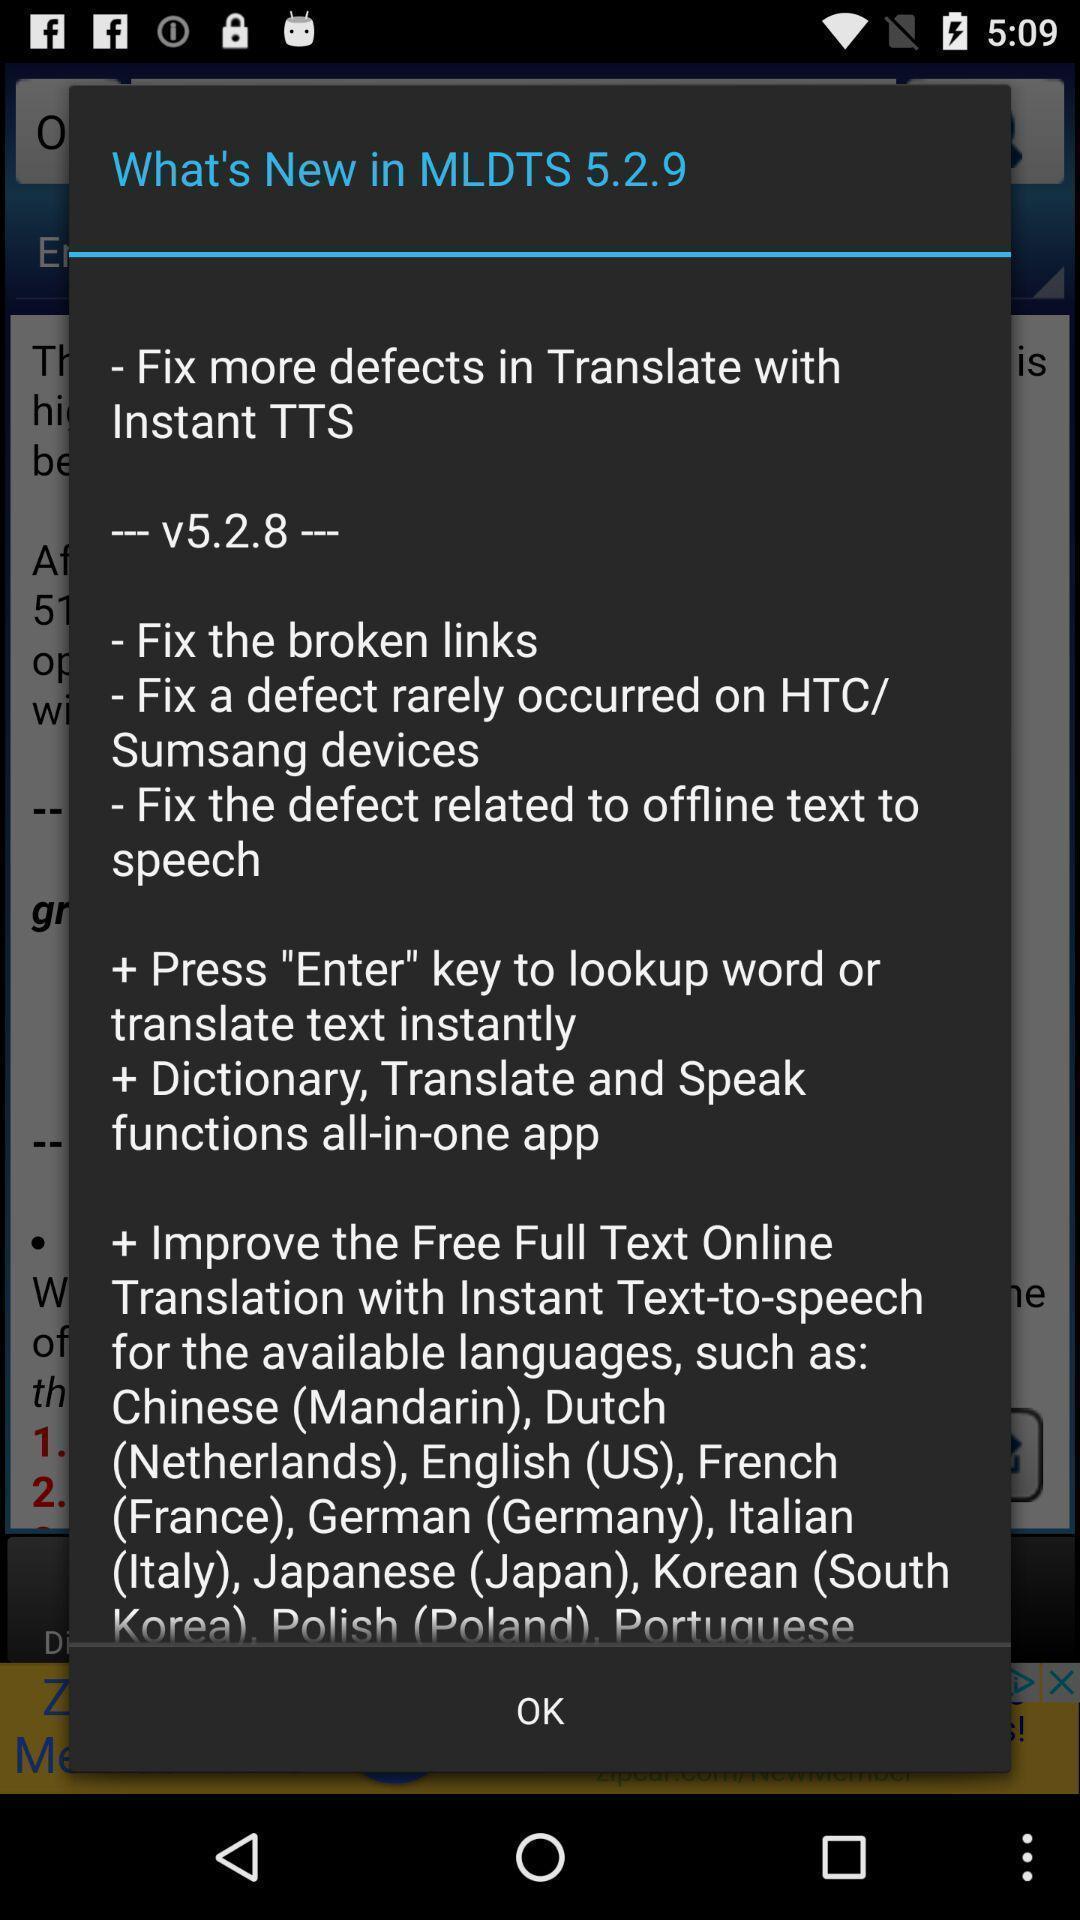Summarize the information in this screenshot. Pop up showing details of a version on an app. 